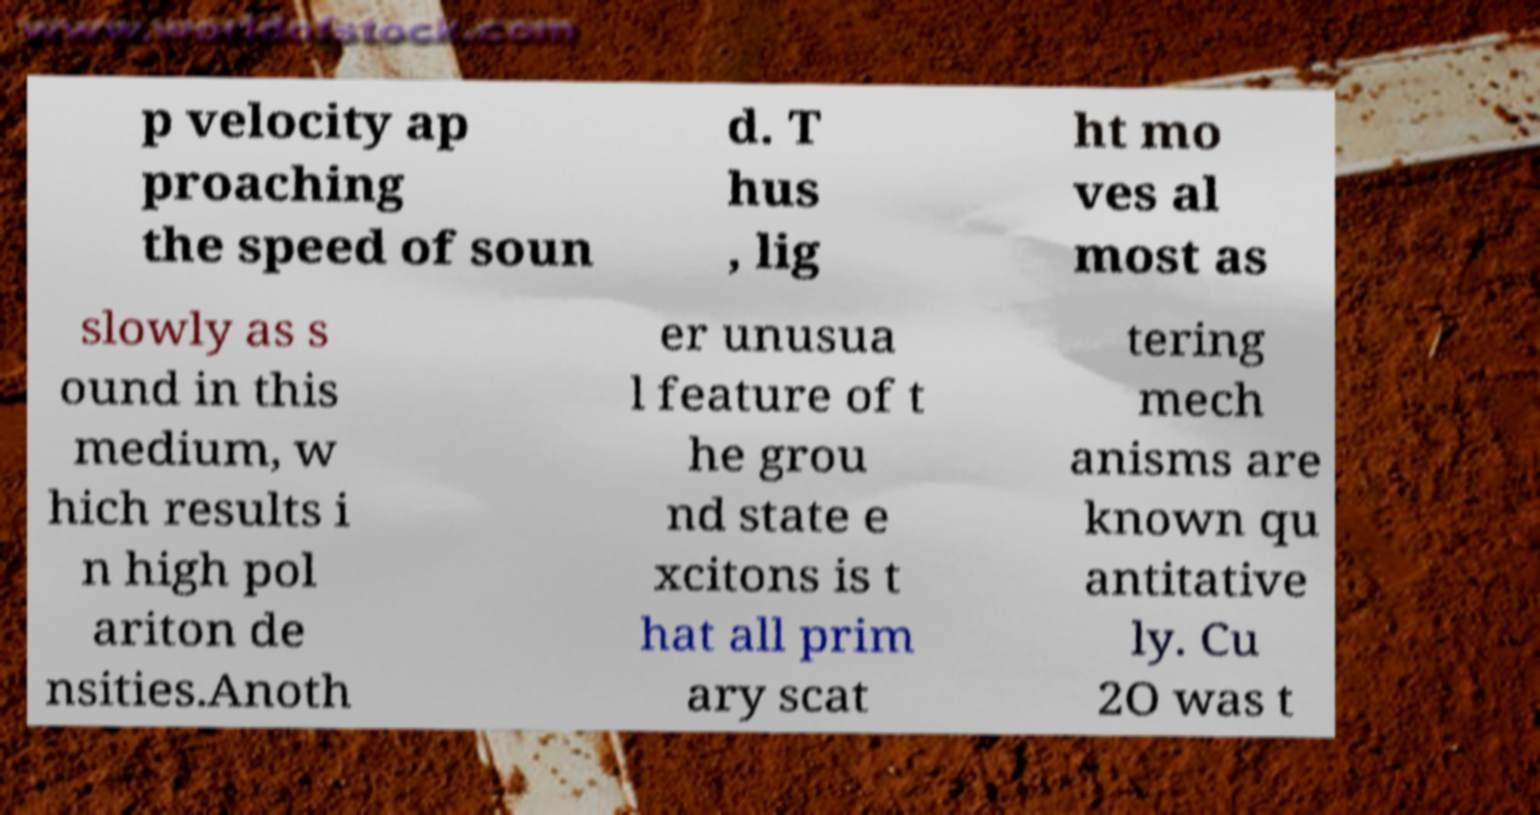What messages or text are displayed in this image? I need them in a readable, typed format. p velocity ap proaching the speed of soun d. T hus , lig ht mo ves al most as slowly as s ound in this medium, w hich results i n high pol ariton de nsities.Anoth er unusua l feature of t he grou nd state e xcitons is t hat all prim ary scat tering mech anisms are known qu antitative ly. Cu 2O was t 